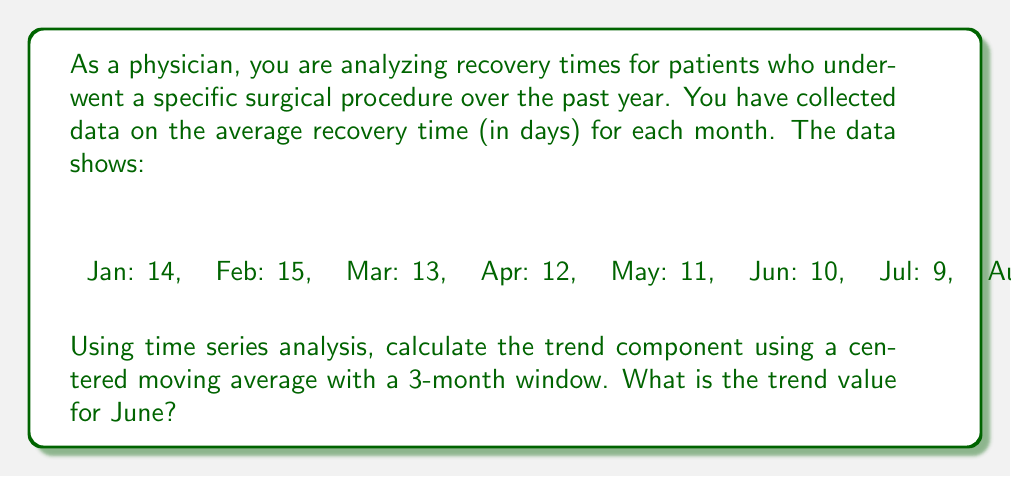Give your solution to this math problem. To solve this problem, we'll follow these steps:

1) First, we need to understand what a centered moving average is. For a 3-month window, we calculate the average of the current month, the previous month, and the next month.

2) The formula for a 3-month centered moving average is:

   $$CMA_t = \frac{Y_{t-1} + Y_t + Y_{t+1}}{3}$$

   Where $CMA_t$ is the centered moving average for time $t$, and $Y_t$ is the value at time $t$.

3) Let's calculate the centered moving average for each month, starting from February and ending in November:

   Feb: $\frac{14 + 15 + 13}{3} = 14$
   Mar: $\frac{15 + 13 + 12}{3} = 13.33$
   Apr: $\frac{13 + 12 + 11}{3} = 12$
   May: $\frac{12 + 11 + 10}{3} = 11$
   Jun: $\frac{11 + 10 + 9}{3} = 10$
   Jul: $\frac{10 + 9 + 8}{3} = 9$
   Aug: $\frac{9 + 8 + 7}{3} = 8$
   Sep: $\frac{8 + 7 + 6}{3} = 7$
   Oct: $\frac{7 + 6 + 5}{3} = 6$
   Nov: $\frac{6 + 5 + 4}{3} = 5$

4) The question asks for the trend value for June, which we've calculated as 10.
Answer: The trend value for June using a 3-month centered moving average is 10 days. 